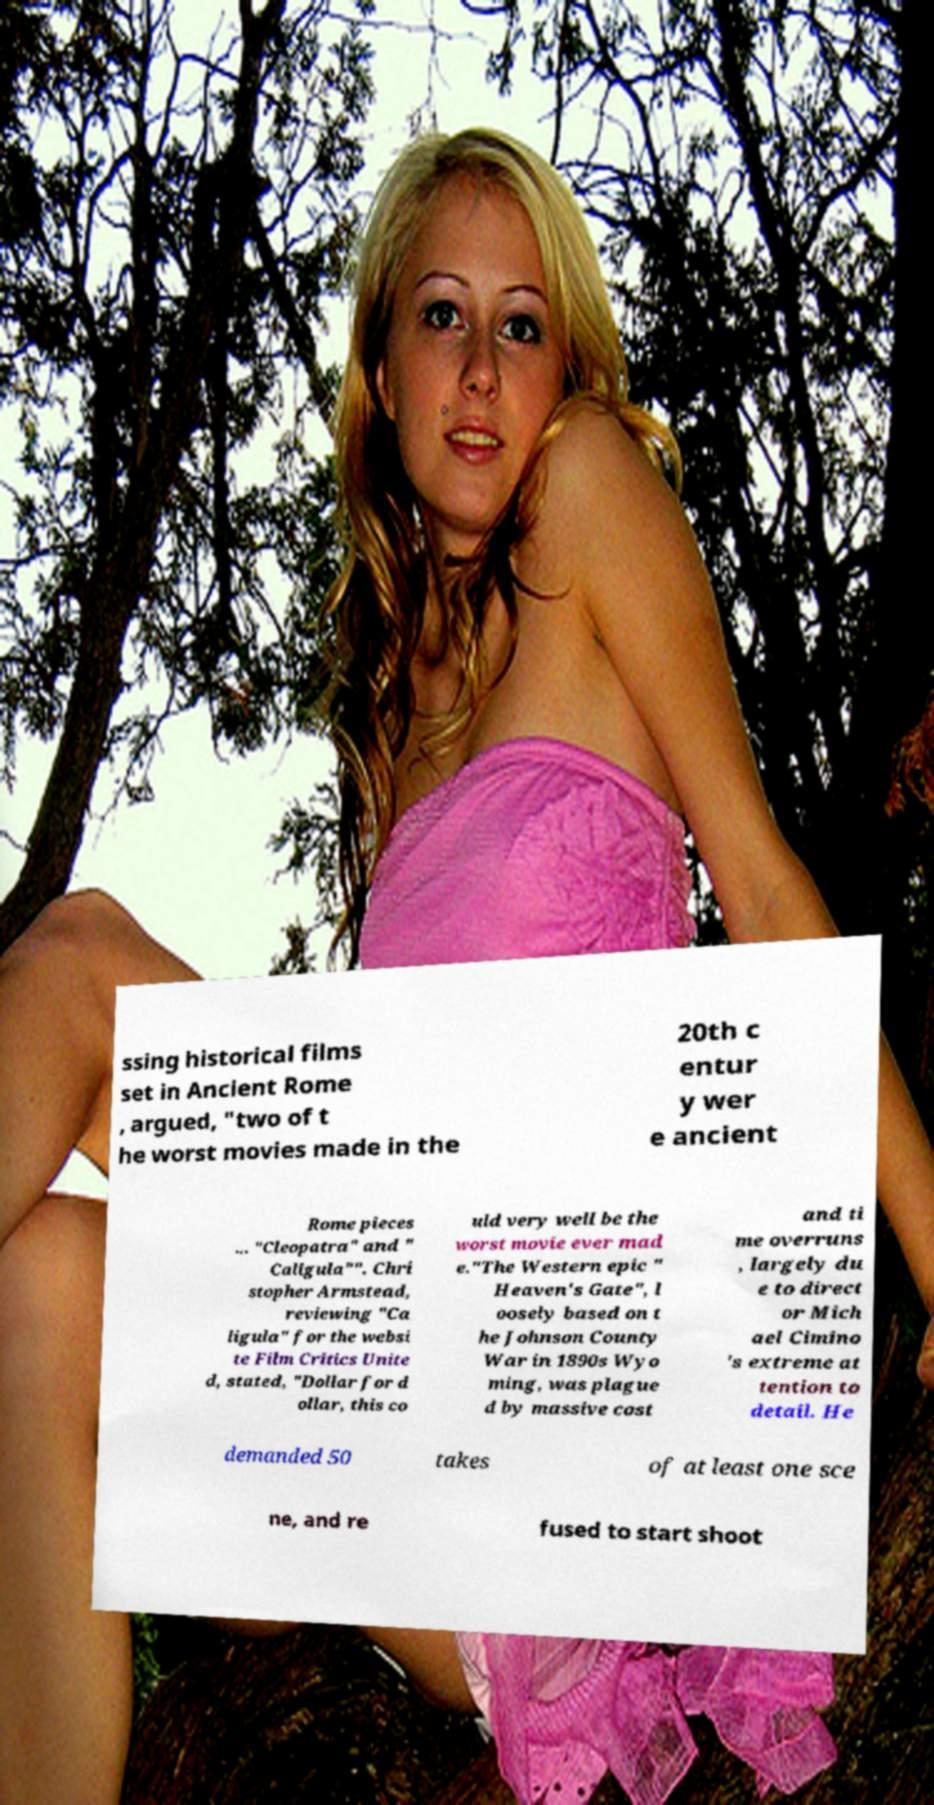Please identify and transcribe the text found in this image. ssing historical films set in Ancient Rome , argued, "two of t he worst movies made in the 20th c entur y wer e ancient Rome pieces ... "Cleopatra" and " Caligula"". Chri stopher Armstead, reviewing "Ca ligula" for the websi te Film Critics Unite d, stated, "Dollar for d ollar, this co uld very well be the worst movie ever mad e."The Western epic " Heaven's Gate", l oosely based on t he Johnson County War in 1890s Wyo ming, was plague d by massive cost and ti me overruns , largely du e to direct or Mich ael Cimino 's extreme at tention to detail. He demanded 50 takes of at least one sce ne, and re fused to start shoot 